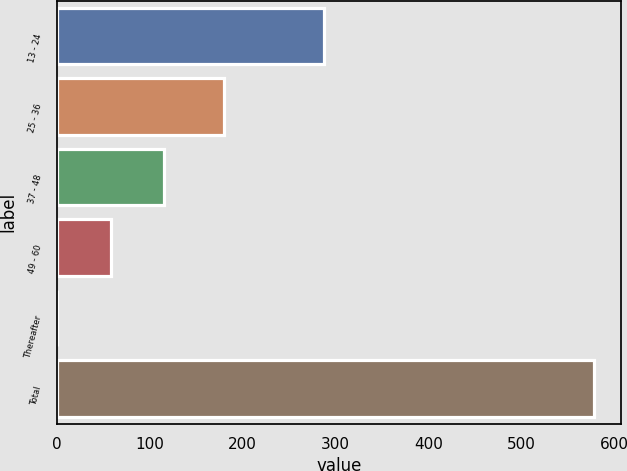<chart> <loc_0><loc_0><loc_500><loc_500><bar_chart><fcel>13 - 24<fcel>25 - 36<fcel>37 - 48<fcel>49 - 60<fcel>Thereafter<fcel>Total<nl><fcel>287.2<fcel>179.6<fcel>115.7<fcel>57.95<fcel>0.2<fcel>577.7<nl></chart> 